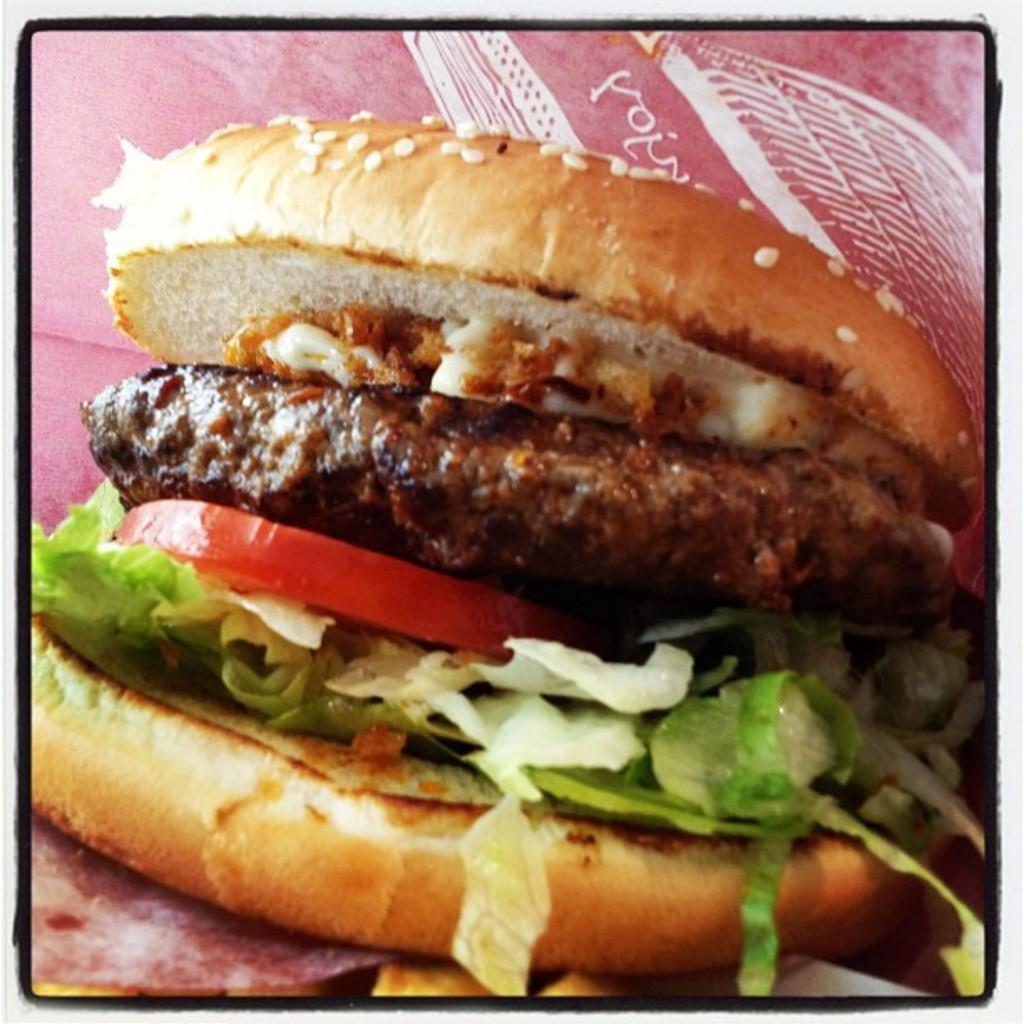In one or two sentences, can you explain what this image depicts? In this image we can see some food item. 